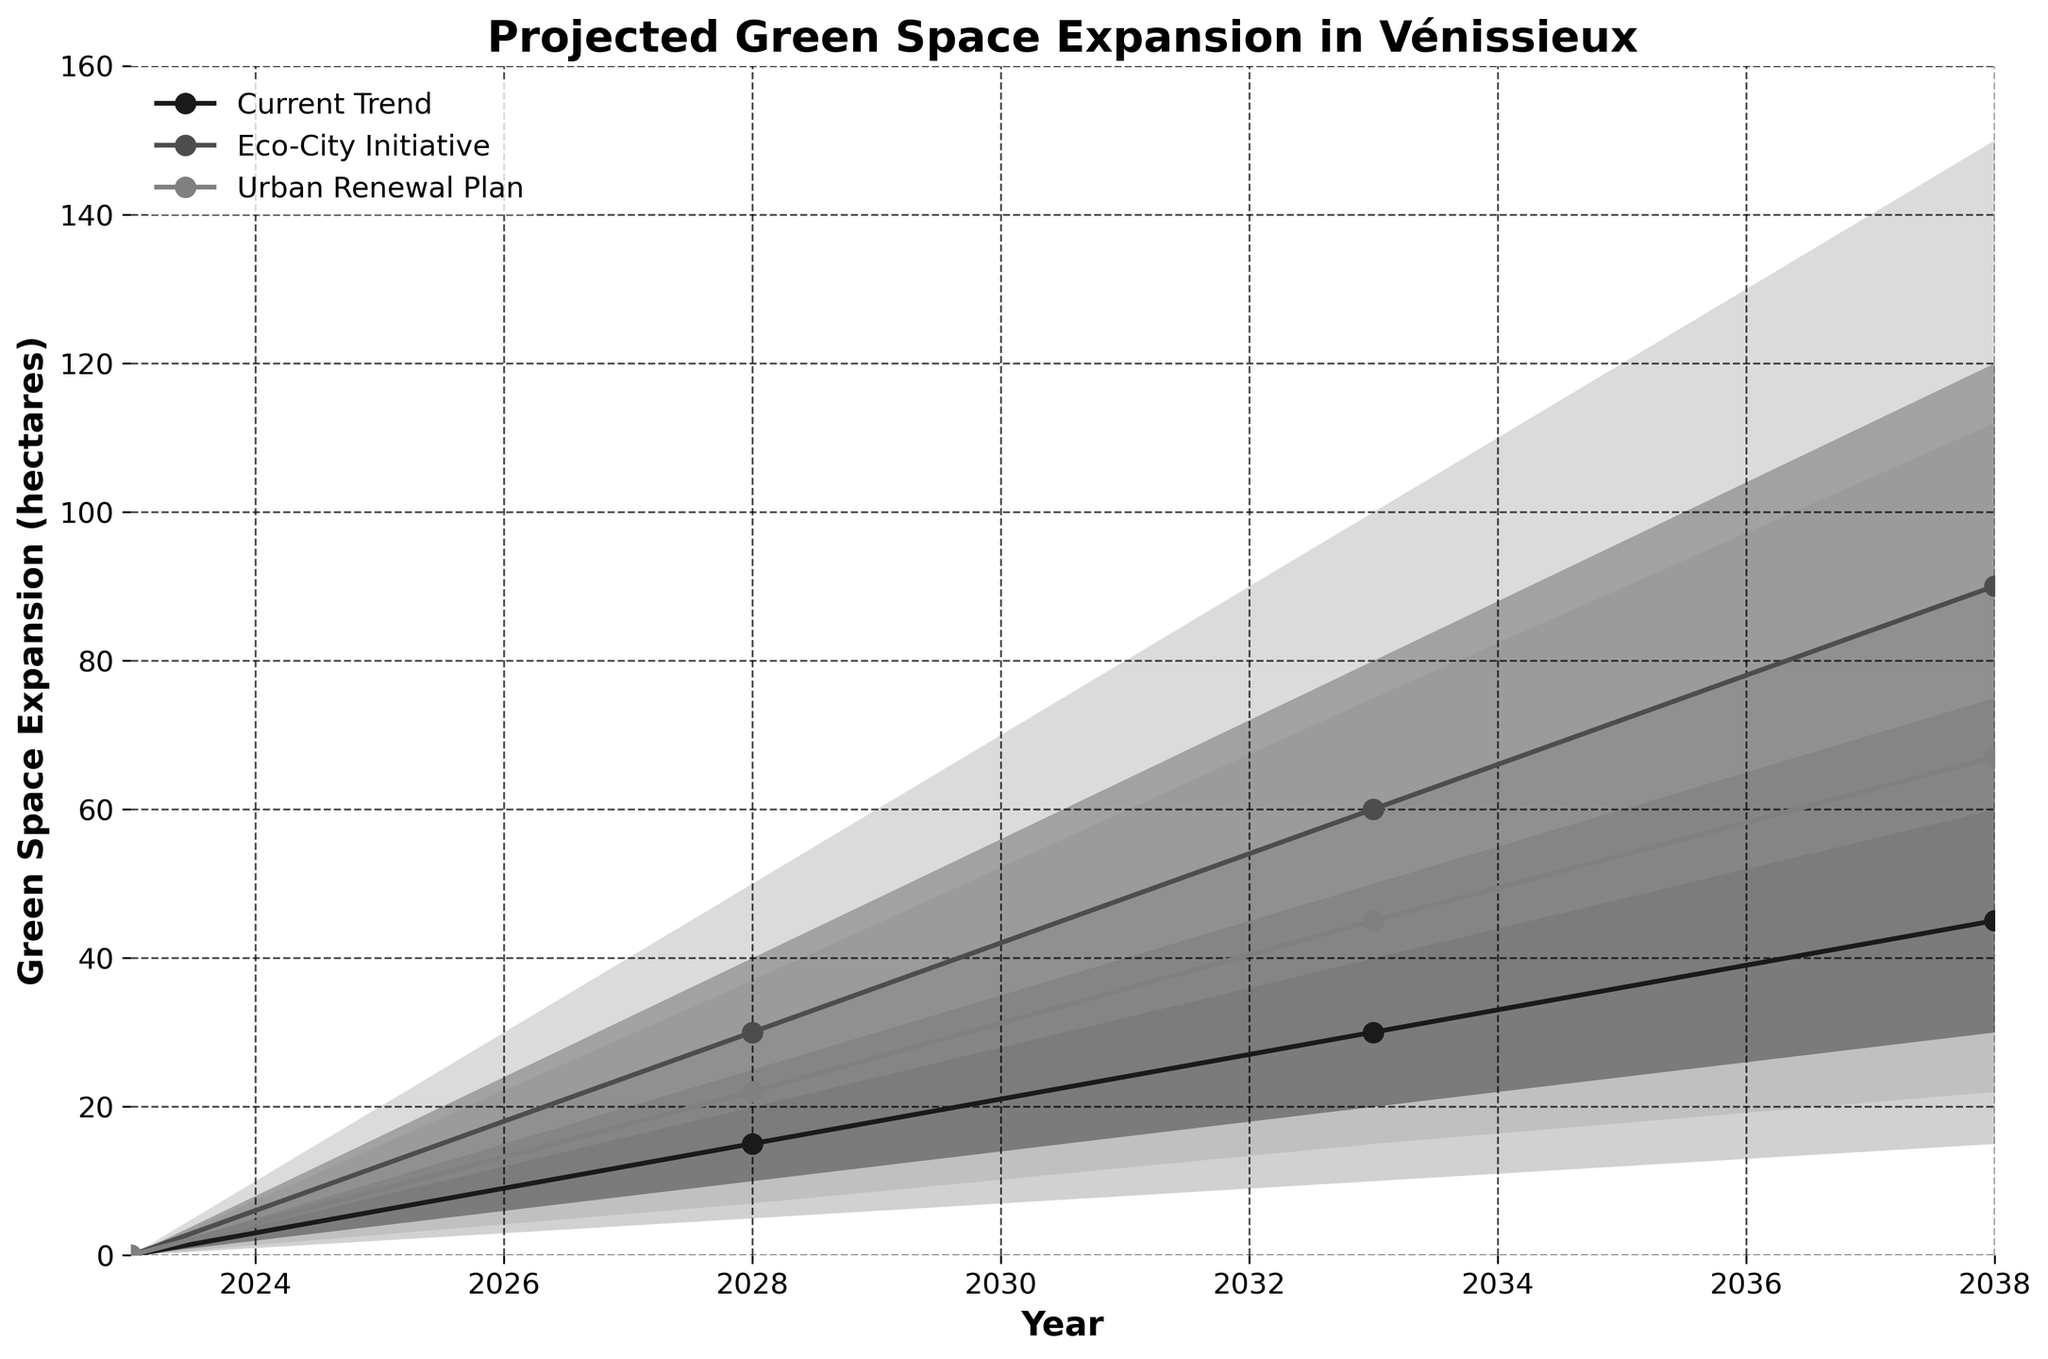What's the title of the figure? The title of the figure is typically located at the top center of the chart area. In this case, the title is provided in the code as 'Projected Green Space Expansion in Vénissieux'.
Answer: Projected Green Space Expansion in Vénissieux How many scenarios are shown in the figure? The figure includes projections for green space expansion under three different scenarios: 'Current Trend', 'Eco-City Initiative', and 'Urban Renewal Plan'. This information can be deduced by observing the legend and the labels in the figure.
Answer: Three Which scenario has the highest central estimate for green space expansion in 2038? To determine this, look at the central estimate data point for the year 2038 for each scenario. The central estimates are: Current Trend (45 hectares), Eco-City Initiative (90 hectares), and Urban Renewal Plan (67 hectares).
Answer: Eco-City Initiative What's the range of green space expansion under the 'Current Trend' scenario in 2033? The range is determined by the lower and upper bounds for 2033 under the 'Current Trend' scenario. Referring to the data, it ranges from 10 to 50 hectares.
Answer: 10 to 50 hectares How much more green space is projected under the 'Eco-City Initiative' compared to the 'Current Trend' in 2028 according to their central estimates? For 2028, the central estimate for the 'Eco-City Initiative' is 30 hectares, and for the 'Current Trend' it is 15 hectares. Subtract the 'Current Trend' value from the 'Eco-City Initiative' value: 30 - 15 = 15 hectares.
Answer: 15 hectares Which scenario shows the narrowest range of projections in 2028? The range is found by subtracting the lower bound from the upper bound for each scenario in 2028. 'Current Trend' has a range of 25 - 5 = 20 hectares; 'Eco-City Initiative' has a range of 50 - 10 = 40 hectares; 'Urban Renewal Plan' has a range of 37 - 7 = 30 hectares. The narrowest range is 'Current Trend' with 20 hectares.
Answer: Current Trend What is the average of the central estimates for green space expansion across all three scenarios in 2028? To find the average, sum the central estimates for each scenario in 2028 and divide by the number of scenarios. Central estimates: Current Trend (15 hectares), Eco-City Initiative (30 hectares), Urban Renewal Plan (22 hectares). Sum = 15 + 30 + 22 = 67. Average = 67 / 3 = 22.33 hectares.
Answer: 22.33 hectares In 2038, what is the difference between the upper bound of the 'Eco-City Initiative' and the 'Urban Renewal Plan' scenarios? Refer to the upper bounds for 2038 for both scenarios. 'Eco-City Initiative' is 150 hectares, 'Urban Renewal Plan' is 112 hectares. Subtract the 'Urban Renewal Plan' value from the 'Eco-City Initiative' value: 150 - 112 = 38 hectares.
Answer: 38 hectares Which scenario shows the greatest increase in the central estimate from 2028 to 2033? Calculate the increase for each scenario between 2028 and 2033. 'Current Trend': 30 - 15 = 15 hectares; 'Eco-City Initiative': 60 - 30 = 30 hectares; 'Urban Renewal Plan': 45 - 22 = 23 hectares. 'Eco-City Initiative' shows the greatest increase of 30 hectares.
Answer: Eco-City Initiative 